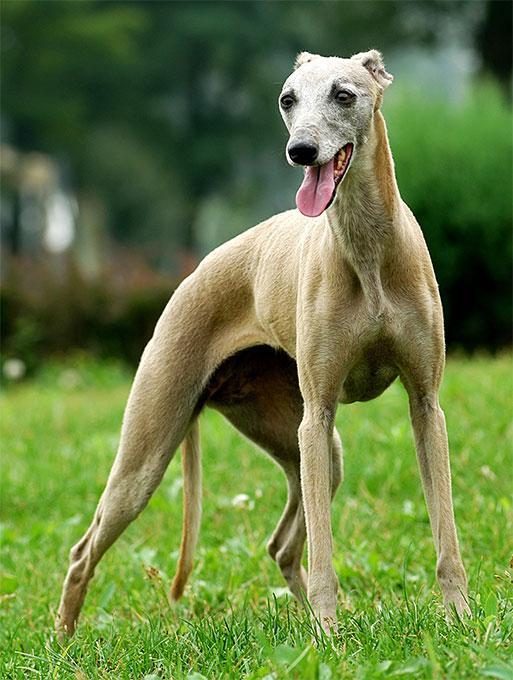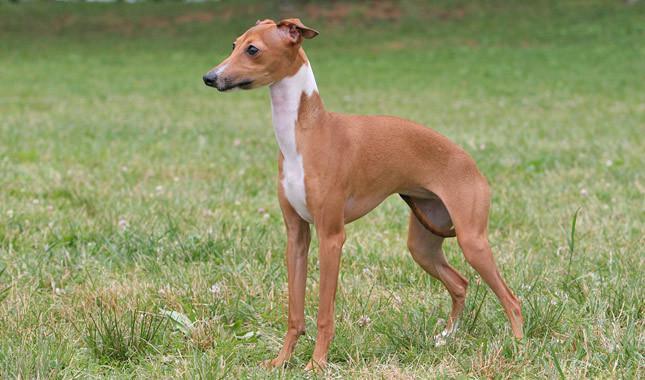The first image is the image on the left, the second image is the image on the right. Considering the images on both sides, is "The dog in the right image is standing and facing left" valid? Answer yes or no. Yes. The first image is the image on the left, the second image is the image on the right. Given the left and right images, does the statement "Both of the dogs are wearing collars." hold true? Answer yes or no. No. 